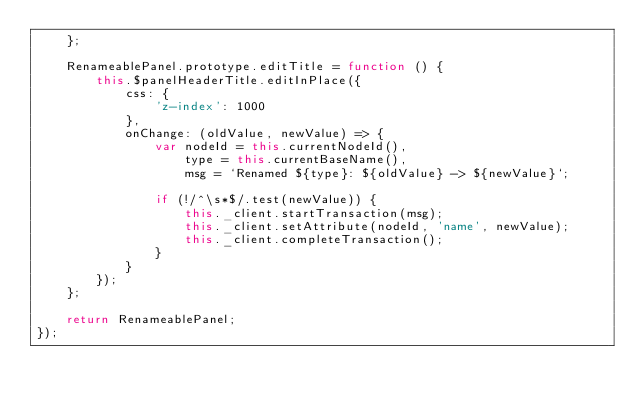Convert code to text. <code><loc_0><loc_0><loc_500><loc_500><_JavaScript_>    };

    RenameablePanel.prototype.editTitle = function () {
        this.$panelHeaderTitle.editInPlace({
            css: {
                'z-index': 1000
            },
            onChange: (oldValue, newValue) => {
                var nodeId = this.currentNodeId(),
                    type = this.currentBaseName(),
                    msg = `Renamed ${type}: ${oldValue} -> ${newValue}`;

                if (!/^\s*$/.test(newValue)) {
                    this._client.startTransaction(msg);
                    this._client.setAttribute(nodeId, 'name', newValue);
                    this._client.completeTransaction();
                }
            }
        });
    };

    return RenameablePanel;
});
</code> 